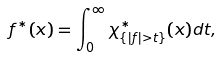<formula> <loc_0><loc_0><loc_500><loc_500>f ^ { * } ( x ) = \int _ { 0 } ^ { \infty } \chi _ { \{ | f | > t \} } ^ { * } ( x ) d t ,</formula> 